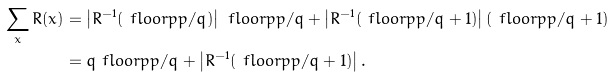<formula> <loc_0><loc_0><loc_500><loc_500>\sum _ { x } R ( x ) & = \left | R ^ { - 1 } ( \ f l o o r { \bar { p } p / q } ) \right | \ f l o o r { \bar { p } p / q } + \left | R ^ { - 1 } ( \ f l o o r { \bar { p } p / q } + 1 ) \right | \left ( \ f l o o r { \bar { p } p / q } + 1 \right ) \\ & = q \ f l o o r { \bar { p } p / q } + \left | R ^ { - 1 } ( \ f l o o r { \bar { p } p / q } + 1 ) \right | .</formula> 